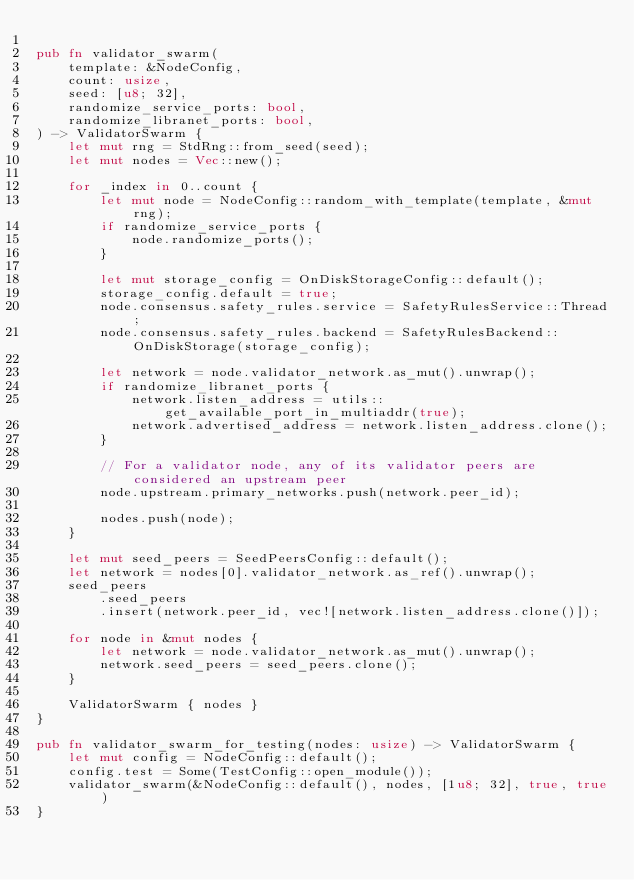<code> <loc_0><loc_0><loc_500><loc_500><_Rust_>
pub fn validator_swarm(
    template: &NodeConfig,
    count: usize,
    seed: [u8; 32],
    randomize_service_ports: bool,
    randomize_libranet_ports: bool,
) -> ValidatorSwarm {
    let mut rng = StdRng::from_seed(seed);
    let mut nodes = Vec::new();

    for _index in 0..count {
        let mut node = NodeConfig::random_with_template(template, &mut rng);
        if randomize_service_ports {
            node.randomize_ports();
        }

        let mut storage_config = OnDiskStorageConfig::default();
        storage_config.default = true;
        node.consensus.safety_rules.service = SafetyRulesService::Thread;
        node.consensus.safety_rules.backend = SafetyRulesBackend::OnDiskStorage(storage_config);

        let network = node.validator_network.as_mut().unwrap();
        if randomize_libranet_ports {
            network.listen_address = utils::get_available_port_in_multiaddr(true);
            network.advertised_address = network.listen_address.clone();
        }

        // For a validator node, any of its validator peers are considered an upstream peer
        node.upstream.primary_networks.push(network.peer_id);

        nodes.push(node);
    }

    let mut seed_peers = SeedPeersConfig::default();
    let network = nodes[0].validator_network.as_ref().unwrap();
    seed_peers
        .seed_peers
        .insert(network.peer_id, vec![network.listen_address.clone()]);

    for node in &mut nodes {
        let network = node.validator_network.as_mut().unwrap();
        network.seed_peers = seed_peers.clone();
    }

    ValidatorSwarm { nodes }
}

pub fn validator_swarm_for_testing(nodes: usize) -> ValidatorSwarm {
    let mut config = NodeConfig::default();
    config.test = Some(TestConfig::open_module());
    validator_swarm(&NodeConfig::default(), nodes, [1u8; 32], true, true)
}
</code> 